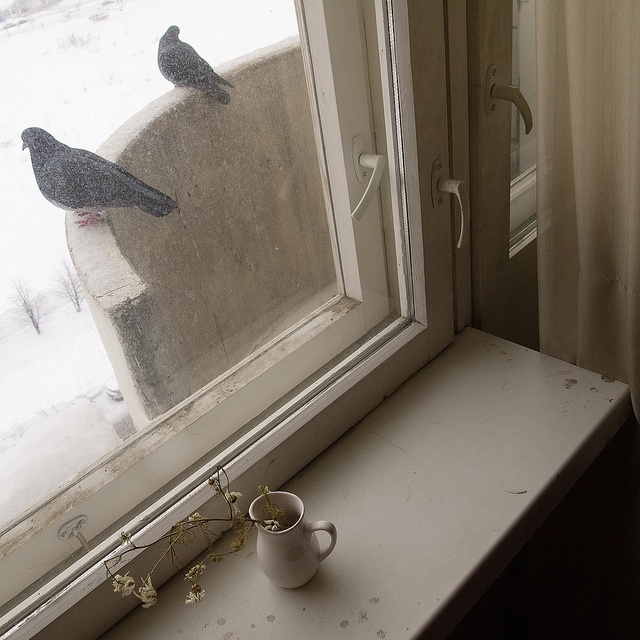Describe the objects in this image and their specific colors. I can see bird in white, gray, and black tones, vase in white, gray, black, and darkgray tones, and bird in white and gray tones in this image. 